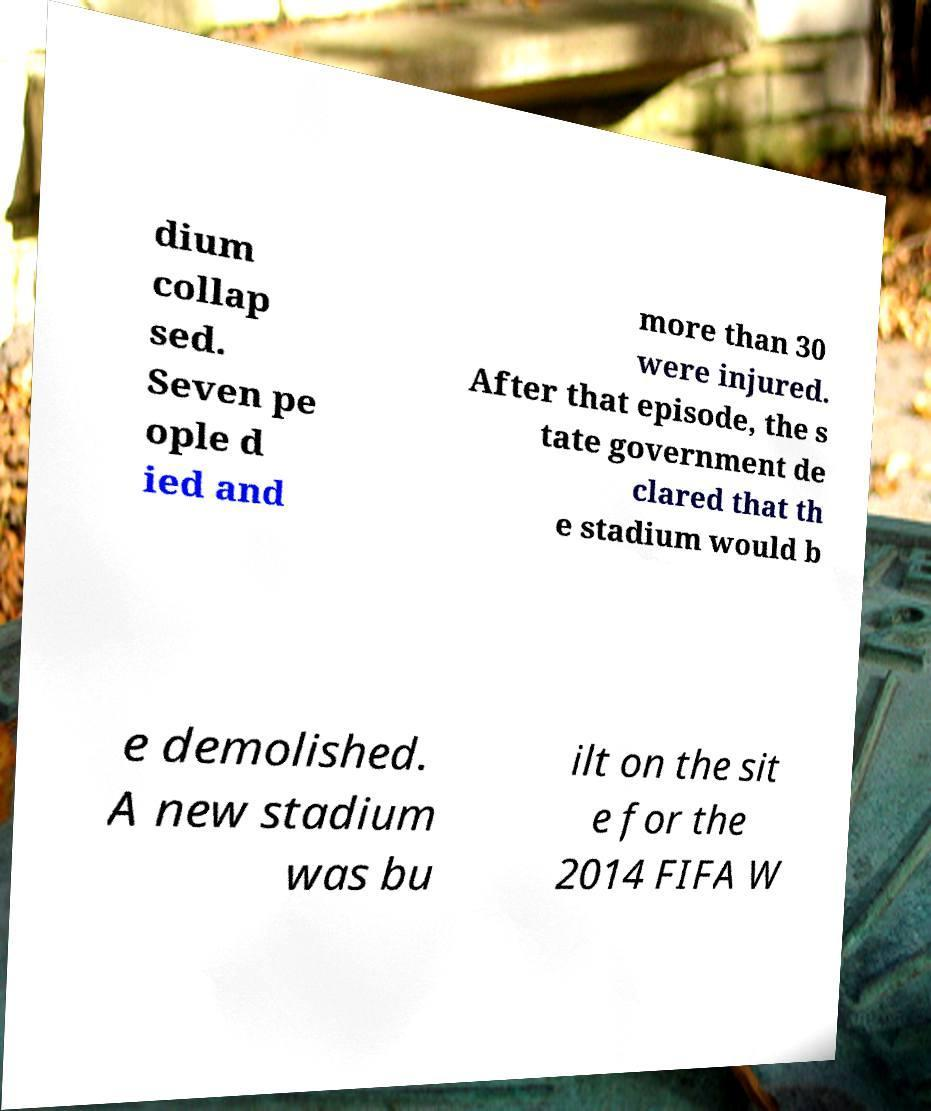Please identify and transcribe the text found in this image. dium collap sed. Seven pe ople d ied and more than 30 were injured. After that episode, the s tate government de clared that th e stadium would b e demolished. A new stadium was bu ilt on the sit e for the 2014 FIFA W 